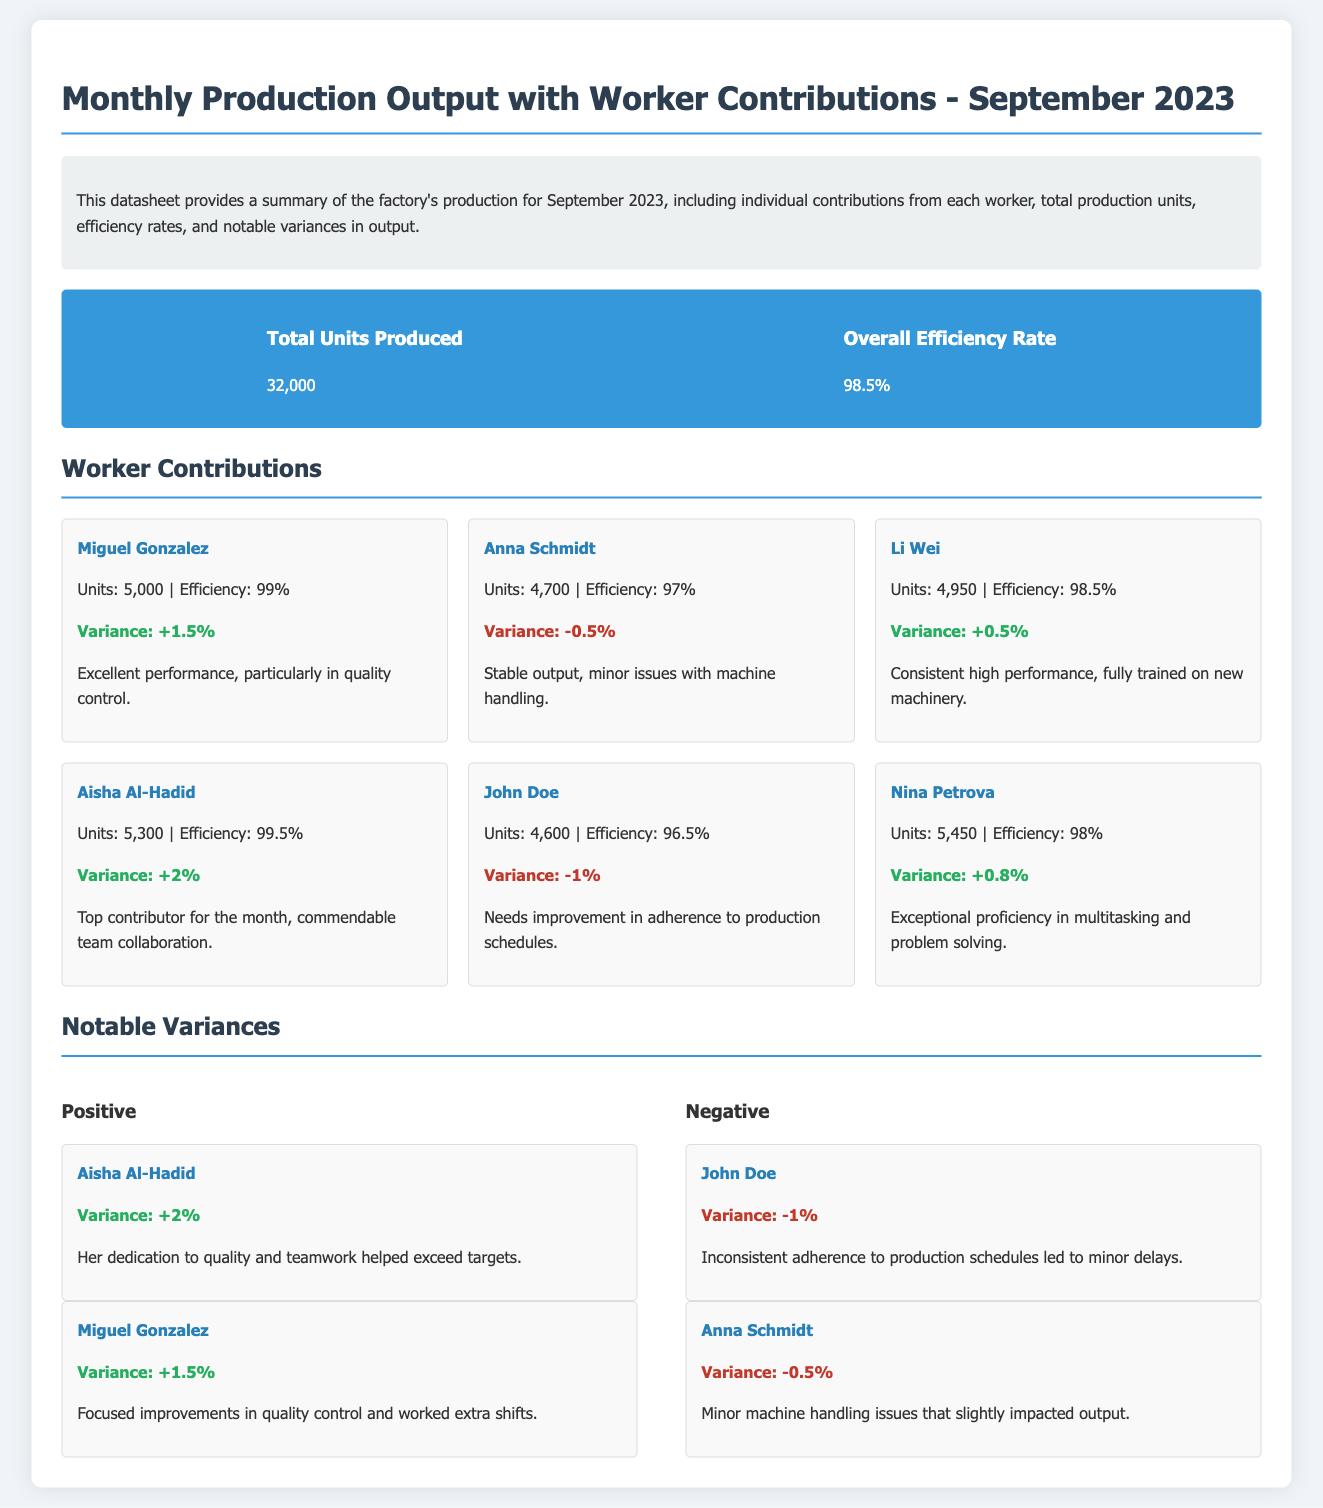What is the total units produced? The total units produced is stated in the summary section of the document, which indicates a total of 32,000 units.
Answer: 32,000 What is the overall efficiency rate? The overall efficiency rate is provided in the total production section, which states it as 98.5%.
Answer: 98.5% Who is the top contributor for the month? The worker with the most units produced is listed as Aisha Al-Hadid with 5,300 units.
Answer: Aisha Al-Hadid What was John Doe's variance in production? John Doe's variance is given in his worker card as -1%.
Answer: -1% Which worker had the highest efficiency? The worker with the highest efficiency rate is Aisha Al-Hadid, with an efficiency of 99.5%.
Answer: Aisha Al-Hadid How many units did Nina Petrova produce? Nina Petrova's production is noted in her worker card as 5,450 units.
Answer: 5,450 What issues did Anna Schmidt face? The document mentions that Anna Schmidt had minor issues with machine handling.
Answer: Minor machine handling issues How many positive variances are listed? The document displays two positive variances in the notable variances section.
Answer: Two What does Li Wei’s performance note mention? Li Wei's performance note highlights consistent high performance and full training on new machinery.
Answer: Consistent high performance, fully trained on new machinery 